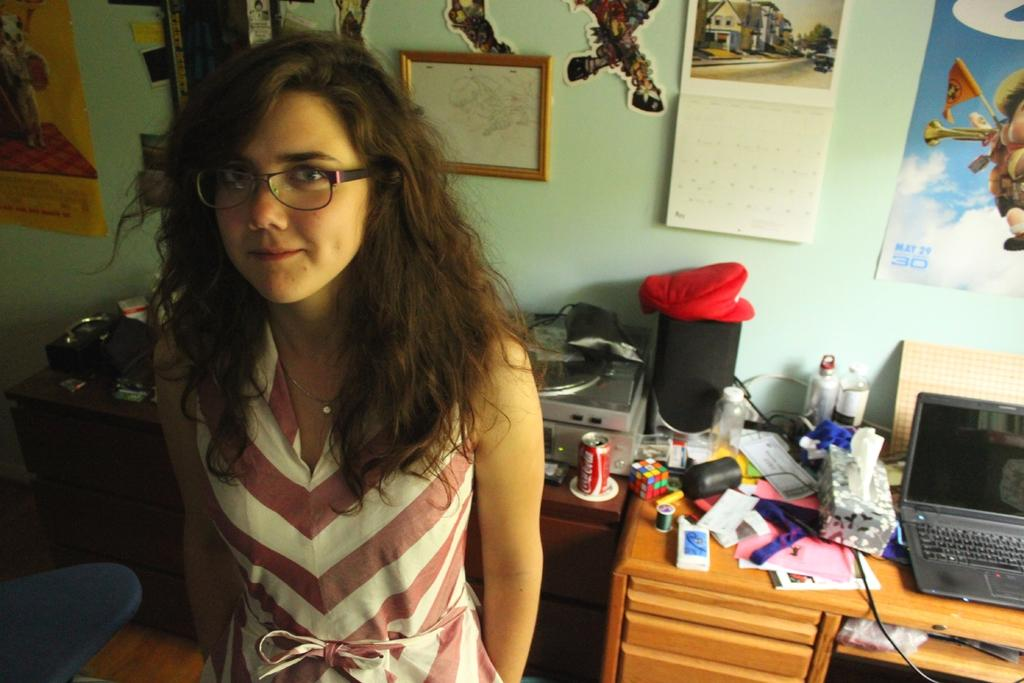Who is present in the image? There is a woman in the image. What is the woman wearing that is related to her vision? The woman is wearing glasses (specs) in the image. What can be seen in the background of the image? There is a desk, a laptop, unspecified "stuffs," a calendar, a frame, and a poster on the wall in the background. What type of letters is the band sending to the woman in the image? There is no mention of letters or a band in the image, so it is not possible to answer that question. 